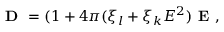Convert formula to latex. <formula><loc_0><loc_0><loc_500><loc_500>D = ( 1 + 4 \pi ( \xi _ { l } + \xi _ { k } E ^ { 2 } ) E ,</formula> 